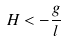<formula> <loc_0><loc_0><loc_500><loc_500>H < - \frac { g } { l }</formula> 